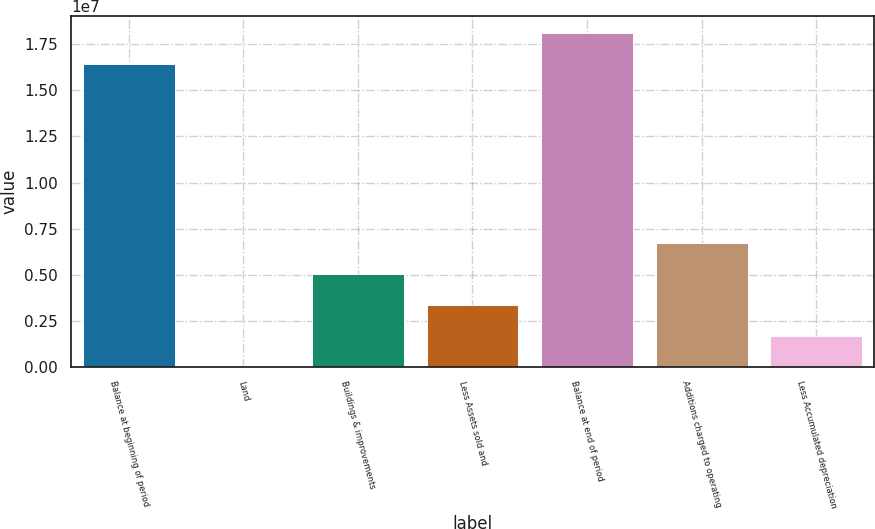<chart> <loc_0><loc_0><loc_500><loc_500><bar_chart><fcel>Balance at beginning of period<fcel>Land<fcel>Buildings & improvements<fcel>Less Assets sold and<fcel>Balance at end of period<fcel>Additions charged to operating<fcel>Less Accumulated depreciation<nl><fcel>1.6455e+07<fcel>33481<fcel>5.03456e+06<fcel>3.36754e+06<fcel>1.8122e+07<fcel>6.70159e+06<fcel>1.70051e+06<nl></chart> 